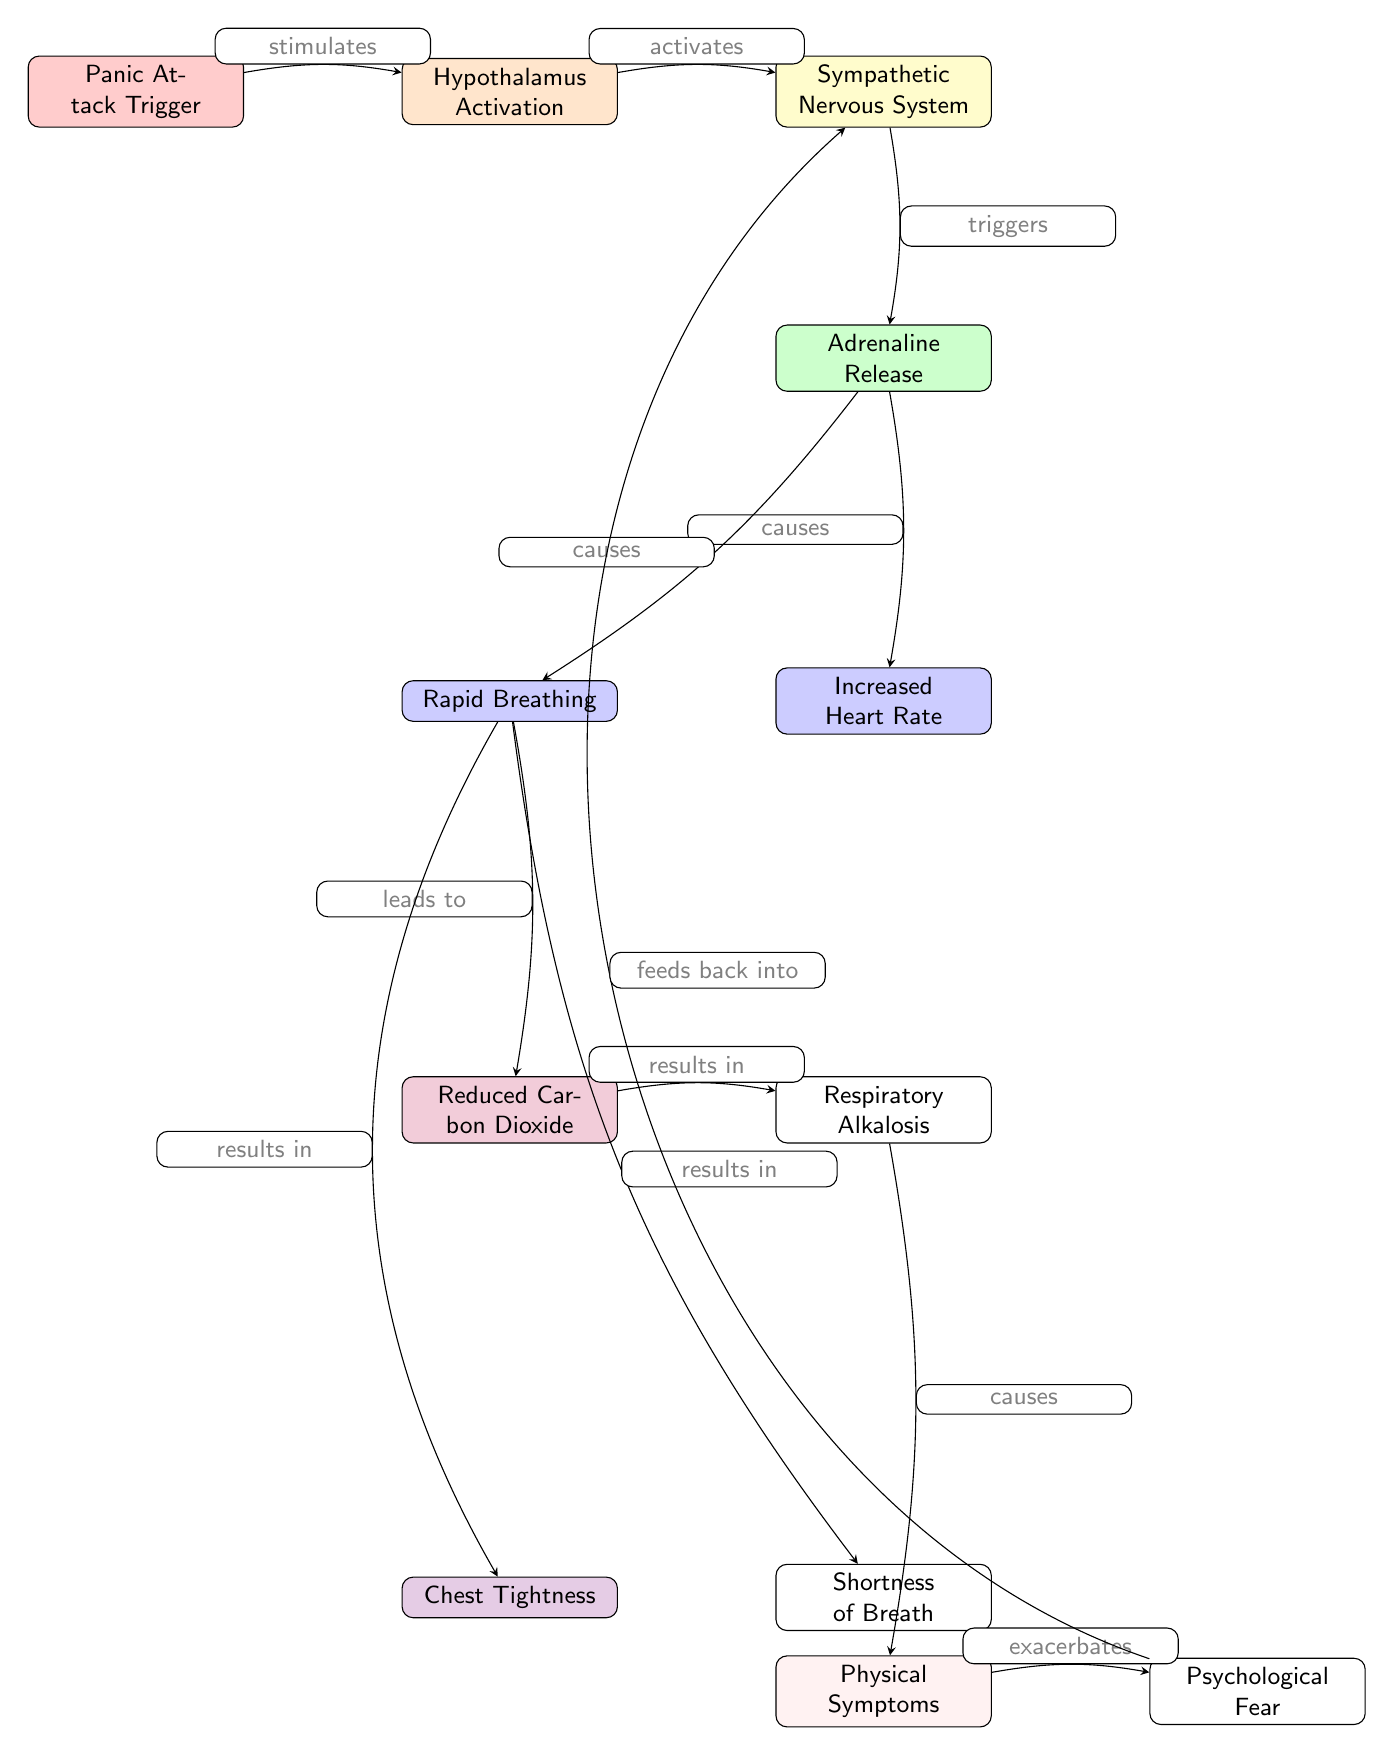What is the first node in the diagram? The first node is labeled "Panic Attack Trigger." This can be identified as it is positioned at the top left of the diagram.
Answer: Panic Attack Trigger How many nodes are present in the diagram? By counting all the distinct labeled shapes in the diagram, there are a total of 12 nodes.
Answer: 12 What action does the Sympathetic Nervous System trigger? The Sympathetic Nervous System triggers "Adrenaline Release," which is directly illustrated with an edge pointing from the node labeled "Sympathetic Nervous System" to the node labeled "Adrenaline Release."
Answer: Adrenaline Release What results from Rapid Breathing? Rapid Breathing results in "Reduced Carbon Dioxide." This connection is indicated by an edge leading from the "Rapid Breathing" node to the "Reduced Carbon Dioxide" node.
Answer: Reduced Carbon Dioxide Which node is affected by Respiratory Alkalosis? The node affected by Respiratory Alkalosis is "Physical Symptoms." This can be seen by tracing the edge leading from the "Respiratory Alkalosis" node to the "Physical Symptoms" node.
Answer: Physical Symptoms How does Psychological Fear relate to the diagram? Psychological Fear is reached by following the path from "Physical Symptoms." This illustrates that heightened physical symptoms can exacerbate feelings of psychological fear, as indicated by the connection between these two nodes.
Answer: Feeds back into What causes Shortness of Breath? Shortness of Breath is caused by Rapid Breathing, as depicted by the direct edge connecting these two nodes in the diagram.
Answer: Rapid Breathing What physiological change leads to Chest Tightness? Chest Tightness is caused by Rapid Breathing, evidenced by the edge connecting these two elements within the diagram.
Answer: Rapid Breathing Which physiological response is directly connected to Adrenaline Release? Two physiological responses are directly connected to Adrenaline Release: Increased Heart Rate and Rapid Breathing. Both nodes have edges leading from "Adrenaline Release."
Answer: Increased Heart Rate, Rapid Breathing What node precedes the item that reduces Carbon Dioxide? The node that precedes the "Reduced Carbon Dioxide" item is "Rapid Breathing," highlighted by the edge that indicates a direct relationship between these two nodes.
Answer: Rapid Breathing 